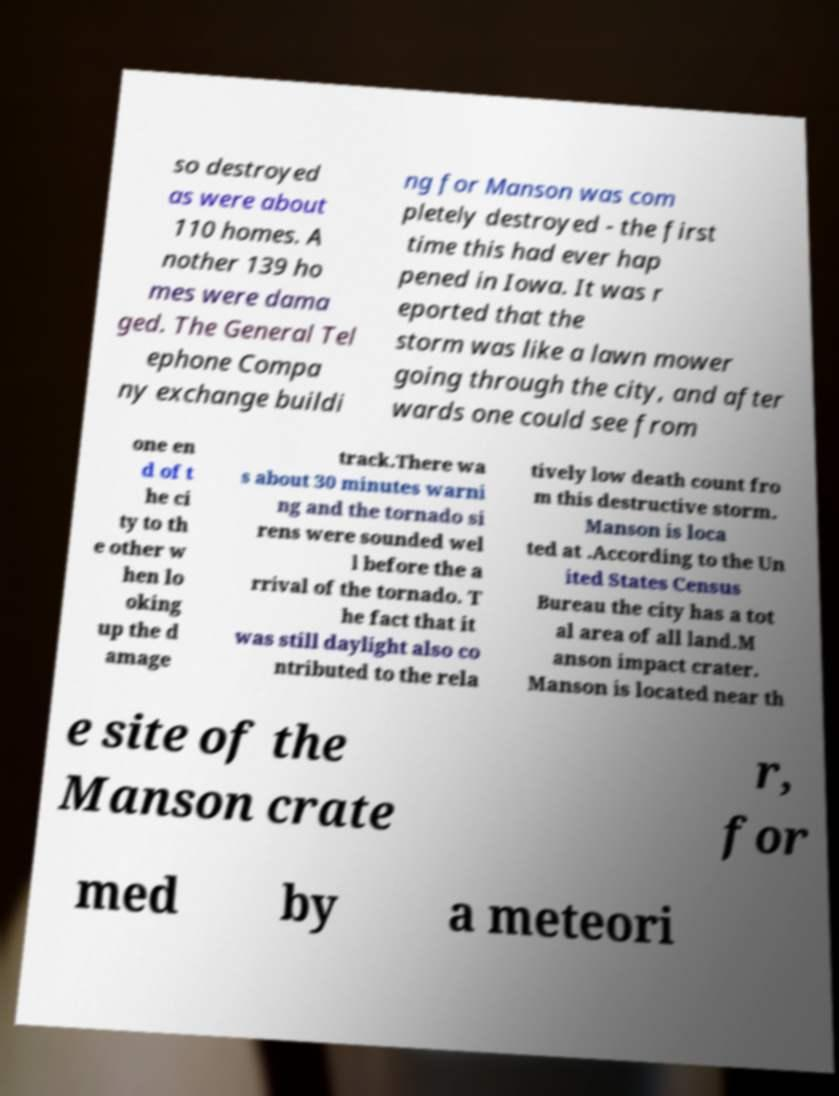Please identify and transcribe the text found in this image. so destroyed as were about 110 homes. A nother 139 ho mes were dama ged. The General Tel ephone Compa ny exchange buildi ng for Manson was com pletely destroyed - the first time this had ever hap pened in Iowa. It was r eported that the storm was like a lawn mower going through the city, and after wards one could see from one en d of t he ci ty to th e other w hen lo oking up the d amage track.There wa s about 30 minutes warni ng and the tornado si rens were sounded wel l before the a rrival of the tornado. T he fact that it was still daylight also co ntributed to the rela tively low death count fro m this destructive storm. Manson is loca ted at .According to the Un ited States Census Bureau the city has a tot al area of all land.M anson impact crater. Manson is located near th e site of the Manson crate r, for med by a meteori 